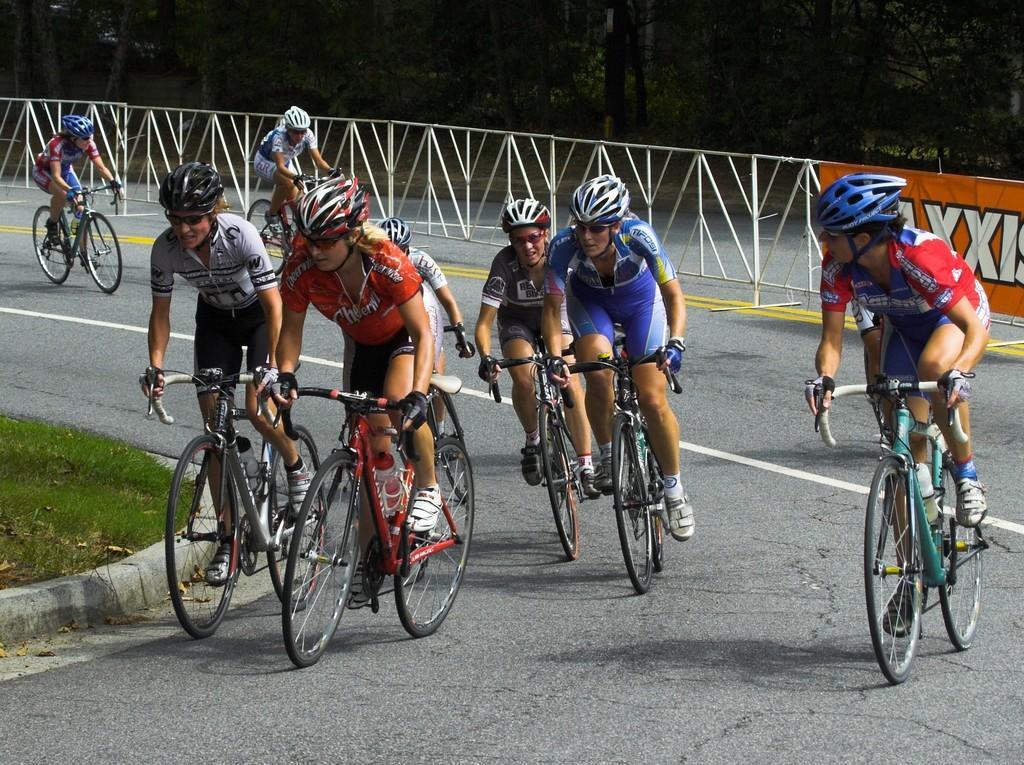In one or two sentences, can you explain what this image depicts? In this image there are groups of persons riding bicycles. On the left side there's grass on the ground. In the background there is a fence and on the fence there is a banner with some text written on it and behind the fence there are trees. 